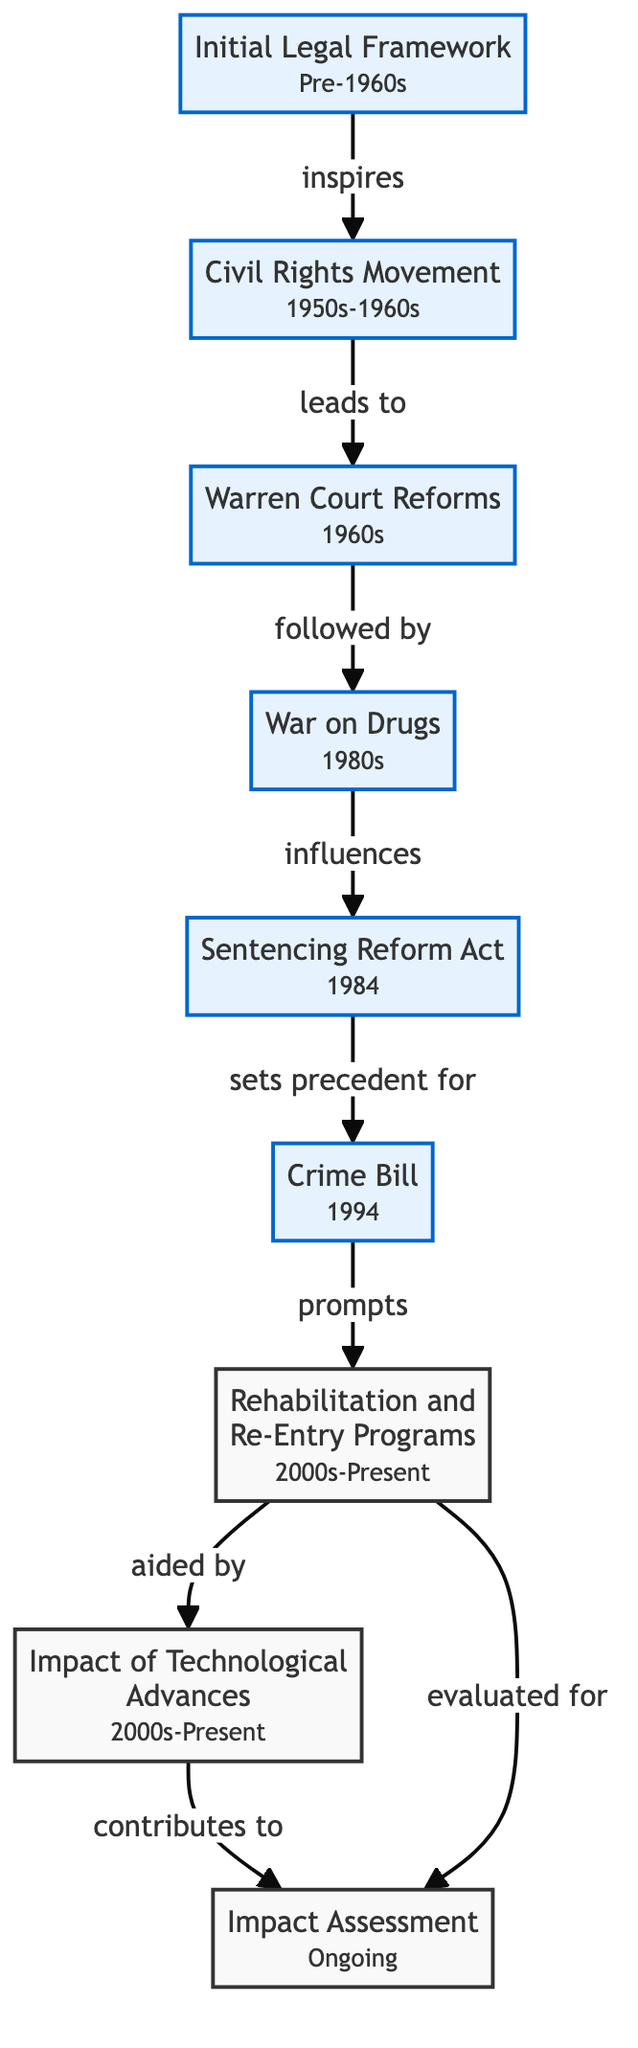What is the first node in the diagram? The first node in the diagram is "Initial Legal Framework," which represents the foundational legal principles and statutes in place before major reforms.
Answer: Initial Legal Framework How many nodes are in the diagram? By counting each individual node listed in the data, there are a total of nine nodes present in the diagram.
Answer: 9 What reform does the “Civil Rights Movement” lead to? The “Civil Rights Movement” leads to the “Warren Court Reforms,” indicating that the former inspired the latter’s changes in justice and equality.
Answer: Warren Court Reforms What impact did the "War on Drugs" have on the legal reform timeline? The "War on Drugs" influenced the "Sentencing Reform Act," showing a direct impact and connection leading to more standardized and severe punishments for federal crimes.
Answer: Sentencing Reform Act Which two nodes are evaluated for their impact on crime rates and recidivism? The nodes "Rehabilitation and Re-Entry Programs" and "Impact Assessment" are both evaluated for their influence on recidivism and other social justice aspects in ongoing analysis.
Answer: Rehabilitation and Re-Entry Programs, Impact Assessment How many times does the "Initial Legal Framework" inspire other reforms? The "Initial Legal Framework" inspires one reform, which is the "Civil Rights Movement."
Answer: 1 Which node follows "Warren Court Reforms" in the timeline? The node that follows "Warren Court Reforms" in the timeline is "War on Drugs," indicating that after the court reforms, this policy emerged.
Answer: War on Drugs What does the "Crime Bill" prompt? The "Crime Bill" prompts "Rehabilitation and Re-Entry Programs," showcasing a shift towards addressing recidivism through these initiatives.
Answer: Rehabilitation and Re-Entry Programs What role do technological advances play according to the diagram? Technological advances contribute to the "Impact Assessment," emphasizing how technology in forensic investigations helps in evaluating the effects of legal reforms.
Answer: Impact Assessment 